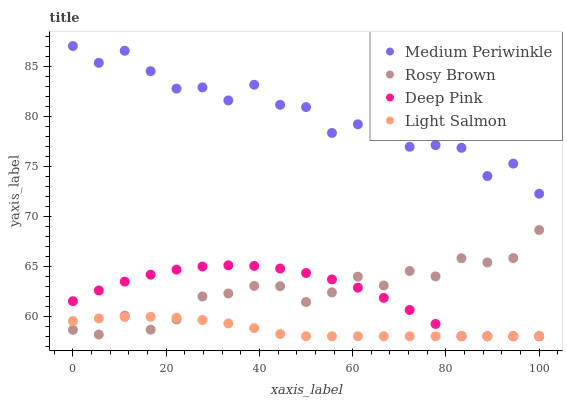Does Light Salmon have the minimum area under the curve?
Answer yes or no. Yes. Does Medium Periwinkle have the maximum area under the curve?
Answer yes or no. Yes. Does Rosy Brown have the minimum area under the curve?
Answer yes or no. No. Does Rosy Brown have the maximum area under the curve?
Answer yes or no. No. Is Light Salmon the smoothest?
Answer yes or no. Yes. Is Medium Periwinkle the roughest?
Answer yes or no. Yes. Is Rosy Brown the smoothest?
Answer yes or no. No. Is Rosy Brown the roughest?
Answer yes or no. No. Does Light Salmon have the lowest value?
Answer yes or no. Yes. Does Rosy Brown have the lowest value?
Answer yes or no. No. Does Medium Periwinkle have the highest value?
Answer yes or no. Yes. Does Rosy Brown have the highest value?
Answer yes or no. No. Is Deep Pink less than Medium Periwinkle?
Answer yes or no. Yes. Is Medium Periwinkle greater than Deep Pink?
Answer yes or no. Yes. Does Deep Pink intersect Rosy Brown?
Answer yes or no. Yes. Is Deep Pink less than Rosy Brown?
Answer yes or no. No. Is Deep Pink greater than Rosy Brown?
Answer yes or no. No. Does Deep Pink intersect Medium Periwinkle?
Answer yes or no. No. 